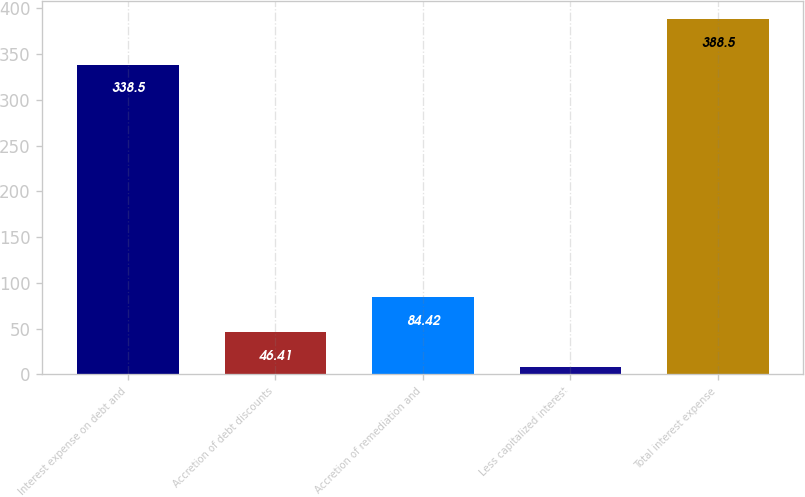Convert chart to OTSL. <chart><loc_0><loc_0><loc_500><loc_500><bar_chart><fcel>Interest expense on debt and<fcel>Accretion of debt discounts<fcel>Accretion of remediation and<fcel>Less capitalized interest<fcel>Total interest expense<nl><fcel>338.5<fcel>46.41<fcel>84.42<fcel>8.4<fcel>388.5<nl></chart> 